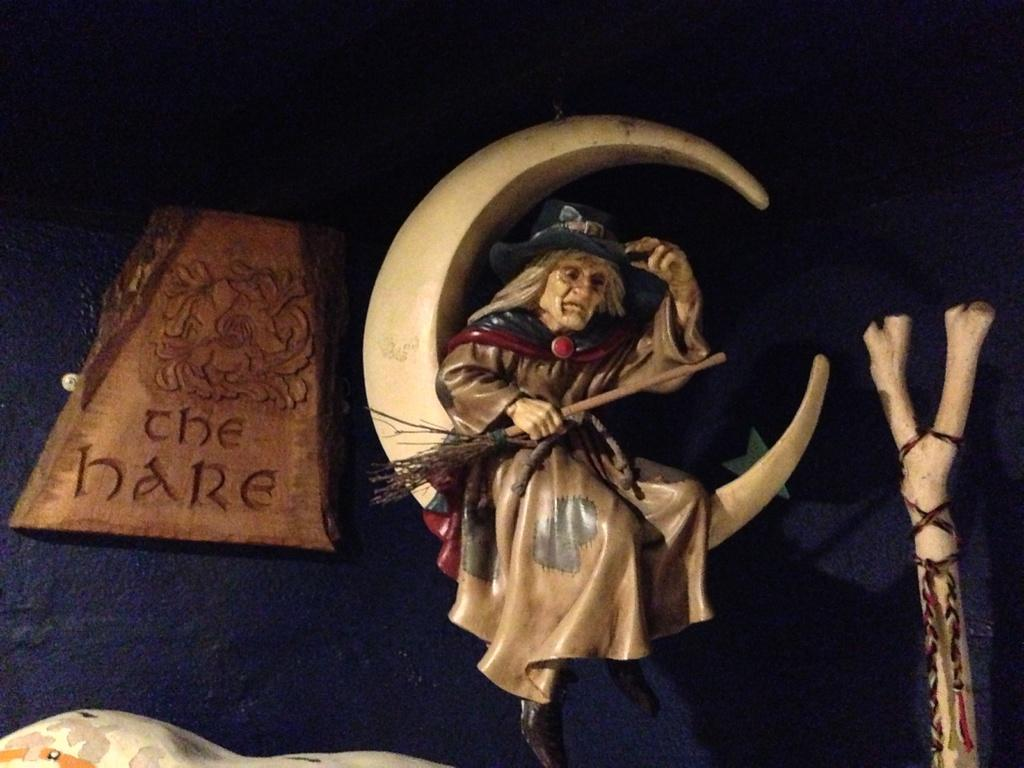What is the main subject of the image? There is a statue in the image. What else can be seen in the image besides the statue? There is a board and various objects in the image. How would you describe the overall lighting in the image? The background of the image is dark. Where is the hen sitting on the throne in the image? There is no hen or throne present in the image. What type of ship can be seen sailing in the background of the image? There is no ship visible in the image; it only features a statue, a board, and various objects. 